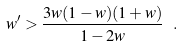<formula> <loc_0><loc_0><loc_500><loc_500>w ^ { \prime } > \frac { 3 w ( 1 - w ) ( 1 + w ) } { 1 - 2 w } \ .</formula> 